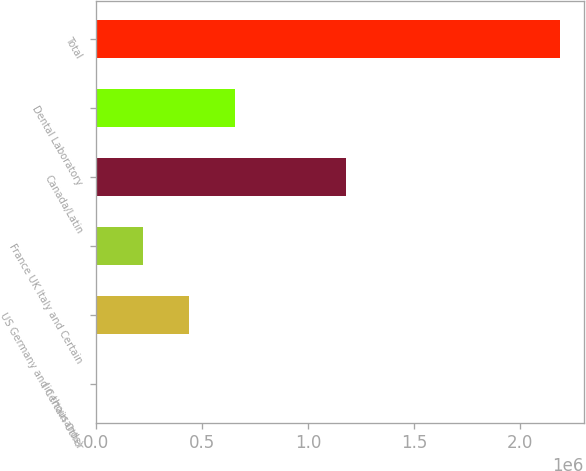Convert chart. <chart><loc_0><loc_0><loc_500><loc_500><bar_chart><fcel>(in thousands)<fcel>US Germany and Certain Other<fcel>France UK Italy and Certain<fcel>Canada/Latin<fcel>Dental Laboratory<fcel>Total<nl><fcel>2011<fcel>439621<fcel>220816<fcel>1.17855e+06<fcel>658427<fcel>2.19006e+06<nl></chart> 